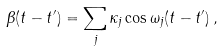Convert formula to latex. <formula><loc_0><loc_0><loc_500><loc_500>\beta ( t - t ^ { \prime } ) = \sum _ { j } \kappa _ { j } \cos \omega _ { j } ( t - t ^ { \prime } ) \, ,</formula> 